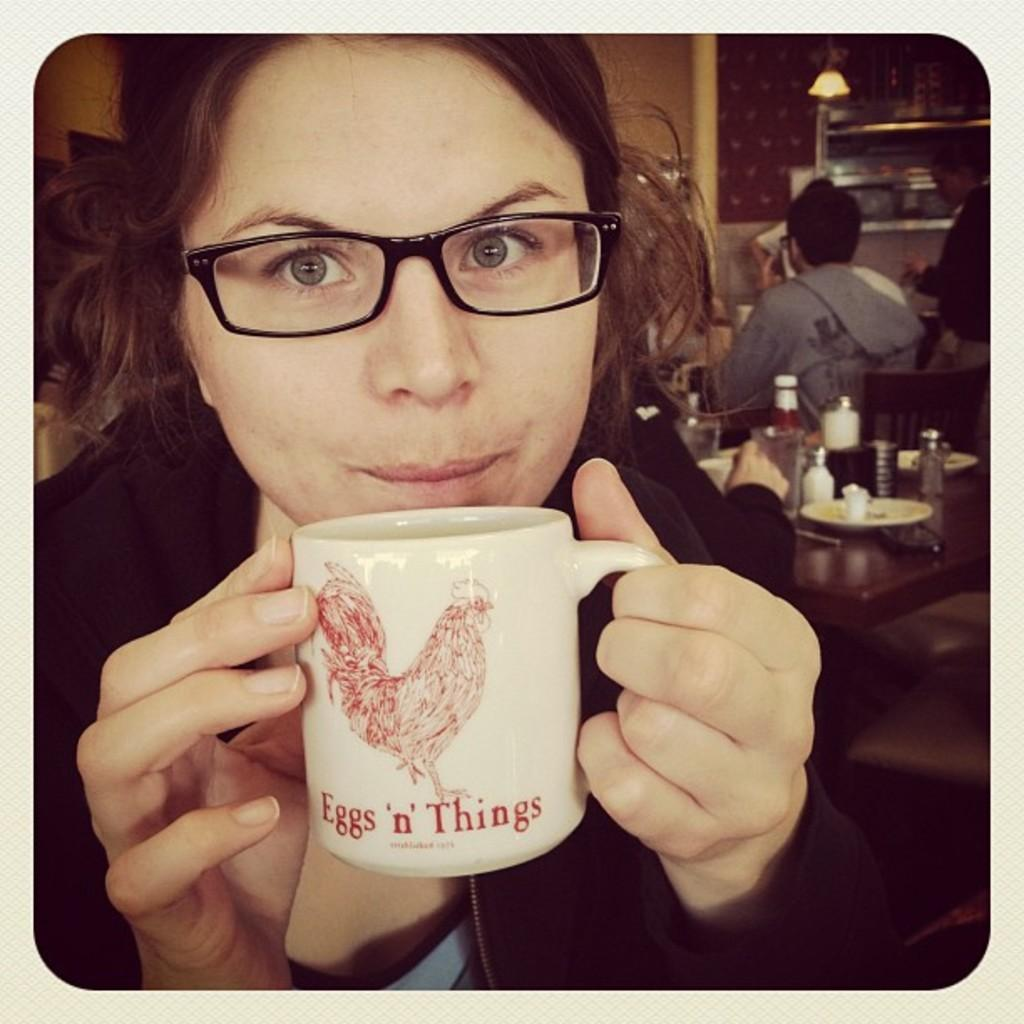Provide a one-sentence caption for the provided image. A woman sips coffee from an Eggs & Things coffee mug. 